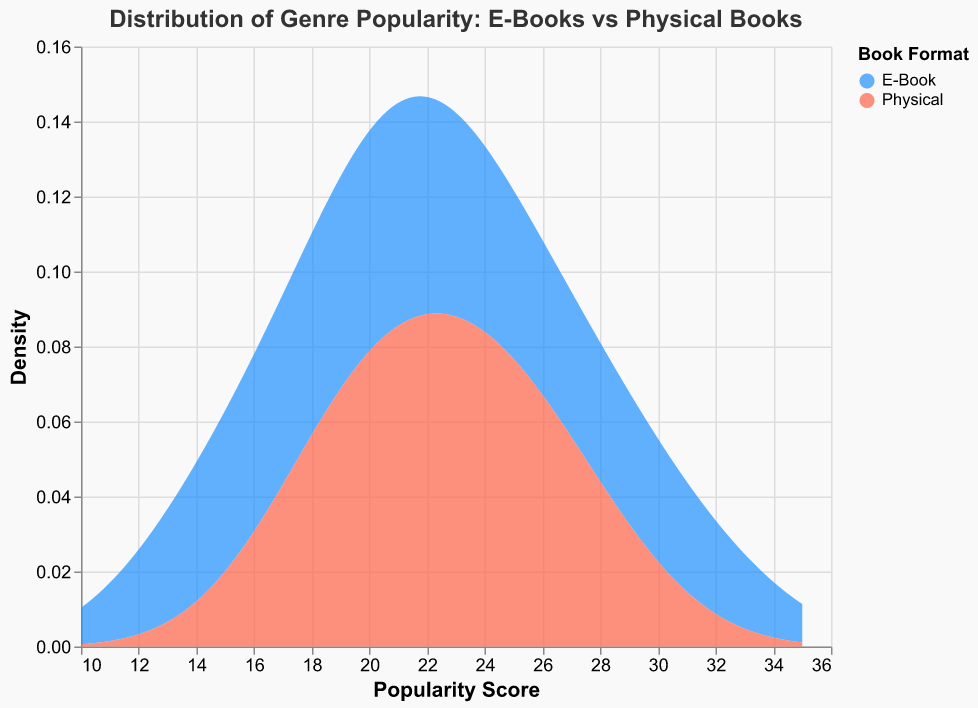How many different book formats are represented in the plot? The plot uses color to distinguish between different book formats. By examining the legend, we see that there are two distinct book formats: E-Book and Physical.
Answer: 2 What color represents Physical books in the plot? The legend indicates that Physical books are represented by a specific color. According to the legend, Physical books are represented by the color red.
Answer: Red What is the title of the plot? The title is displayed at the top of the plot and describes the figure. The title of the plot is "Distribution of Genre Popularity: E-Books vs Physical Books."
Answer: Distribution of Genre Popularity: E-Books vs Physical Books Which format shows a higher density at a popularity score of 20? To determine which format has a higher density at a popularity score of 20, observe the curves at the x-axis value of 20. The blue curve (E-Book) is higher than the red curve (Physical).
Answer: E-Book What's the average maximum popularity score for E-Books and Physical books? To find the average maximum popularity score: First, identify the highest popularity scores for each format. For E-Books, it's 32 (Romance), and for Physical books, it's 28 (Romance). Calculate their average: (32 + 28) / 2 = 30.
Answer: 30 Which genre has the lowest popularity for both formats? The lowest popularity score for both formats can be found by looking at the data points. The genre with the lowest popularity score is Biography with E-Books at 14 and Physical at 24. However, the combined lowest score is Biography for E-Books.
Answer: Biography (E-Books) How does the density distribution for E-Books compare to Physical books in terms of skewness? Skewness can be observed by the density plot's shape. The E-Book density distribution appears slightly right-skewed with higher popularity scores, while the Physical books show a more balanced distribution.
Answer: E-Books: right-skewed; Physical: more balanced Which format has more genres with popularity scores above 25? By checking the data points, note that the genres with scores above 25 are: Mystery (27), Romance (32), Young Adult (29) for E-Books, and Mystery (22), Romance (28), Non-Fiction (25), Young Adult (26) for Physical. Count these occurrences: E-Books: 3; Physical: 4.
Answer: Physical: 4 What is the median popularity score for Physical books? Sort the Physical books' popularity scores: 18, 19, 20, 21, 22, 23, 24, 25, 26, 28. The median is the middle value, which is (22+23)/2 = 22.5.
Answer: 22.5 Identify the popularity score range used for the density plot. The x-axis represents the popularity score range, specified in the extent parameter in the data preparation. The range is 10 to 35.
Answer: 10 to 35 